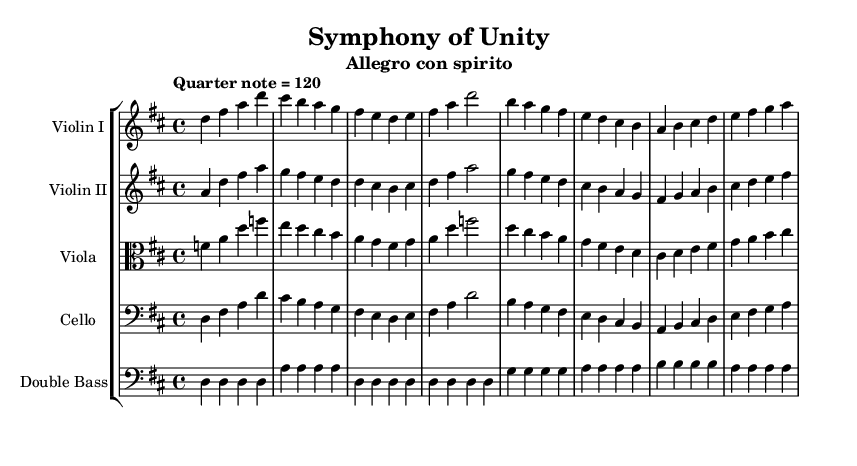What is the key signature of this music? The key signature indicates D major, which has two sharps (F# and C#). We can identify this by looking at the key signature displayed at the beginning of the score, right after the clef.
Answer: D major What is the time signature of this music? The time signature is represented as 4/4, which indicates that there are four beats per measure with a quarter note receiving one beat. This can be seen in the time signature notation at the start of the score.
Answer: 4/4 What is the tempo marking for this piece? The tempo marking of "Quarter note = 120" suggests the speed at which the music should be played. This is shown prominently at the start of the score, directing the performers on the pace.
Answer: Quarter note = 120 How many staves are in this score? The score consists of five staves, each corresponding to different instruments (Violin I, Violin II, Viola, Cello, and Double Bass). We can count the distinct staff lines present in the score to determine this.
Answer: 5 Which instrument plays in the alto clef? The viola part is the only one shown in the alto clef, which is indicated in the staff's clef symbol at the beginning of the viola line. The clef tells us which notes correspond to which lines and spaces on the staff.
Answer: Viola Identify two instruments that are playing the same music material. The Violin I and Cello are playing the same music material as their musical lines are identical for the measures shown. We can observe that the pitches and rhythms in their respective staves match perfectly.
Answer: Violin I and Cello What is the dynamic marking throughout the piece? There are no specific dynamic markings indicated in the music notation provided in the score, suggesting a default dynamic level is maintained throughout the performance. The absence of dynamic markings means that performers can choose suitable dynamics based on their interpretation.
Answer: None 